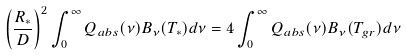Convert formula to latex. <formula><loc_0><loc_0><loc_500><loc_500>\left ( \frac { R _ { * } } { D } \right ) ^ { 2 } \int _ { 0 } ^ { \infty } Q _ { a b s } ( \nu ) B _ { \nu } ( T _ { * } ) d \nu = 4 \int _ { 0 } ^ { \infty } Q _ { a b s } ( \nu ) B _ { \nu } ( T _ { g r } ) d \nu</formula> 